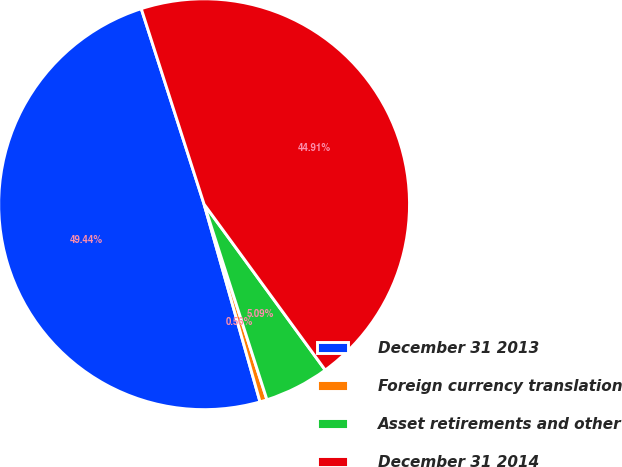Convert chart. <chart><loc_0><loc_0><loc_500><loc_500><pie_chart><fcel>December 31 2013<fcel>Foreign currency translation<fcel>Asset retirements and other<fcel>December 31 2014<nl><fcel>49.44%<fcel>0.56%<fcel>5.09%<fcel>44.91%<nl></chart> 